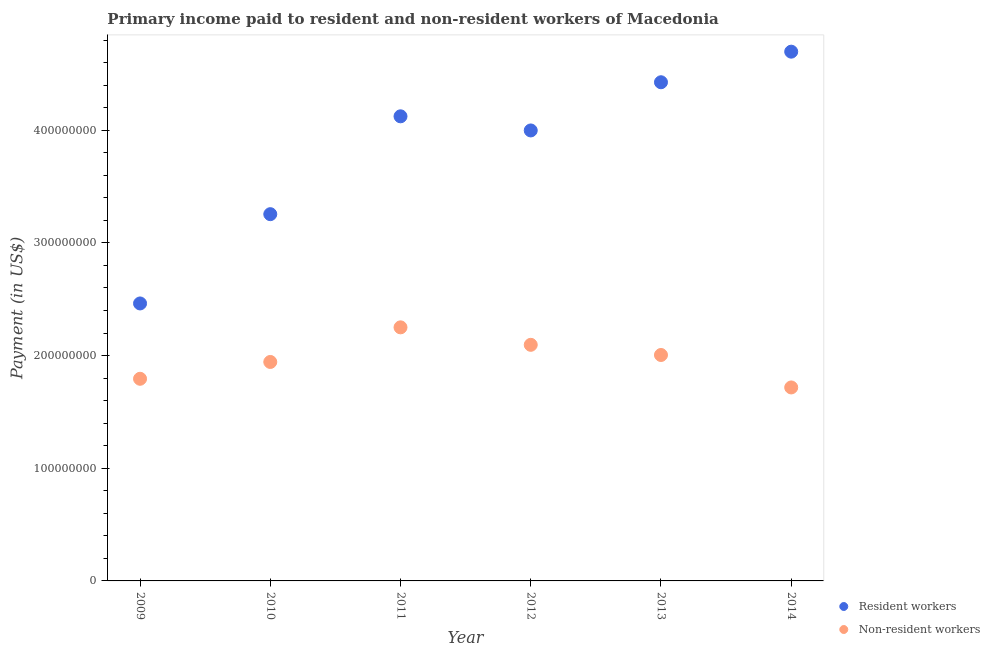Is the number of dotlines equal to the number of legend labels?
Ensure brevity in your answer.  Yes. What is the payment made to resident workers in 2013?
Make the answer very short. 4.43e+08. Across all years, what is the maximum payment made to non-resident workers?
Give a very brief answer. 2.25e+08. Across all years, what is the minimum payment made to non-resident workers?
Offer a very short reply. 1.72e+08. In which year was the payment made to resident workers maximum?
Your answer should be compact. 2014. In which year was the payment made to resident workers minimum?
Make the answer very short. 2009. What is the total payment made to resident workers in the graph?
Your answer should be very brief. 2.30e+09. What is the difference between the payment made to non-resident workers in 2009 and that in 2011?
Provide a succinct answer. -4.56e+07. What is the difference between the payment made to resident workers in 2014 and the payment made to non-resident workers in 2012?
Offer a terse response. 2.60e+08. What is the average payment made to resident workers per year?
Offer a very short reply. 3.83e+08. In the year 2011, what is the difference between the payment made to non-resident workers and payment made to resident workers?
Offer a very short reply. -1.87e+08. What is the ratio of the payment made to non-resident workers in 2010 to that in 2012?
Provide a succinct answer. 0.93. Is the payment made to non-resident workers in 2013 less than that in 2014?
Ensure brevity in your answer.  No. Is the difference between the payment made to resident workers in 2010 and 2014 greater than the difference between the payment made to non-resident workers in 2010 and 2014?
Your response must be concise. No. What is the difference between the highest and the second highest payment made to resident workers?
Make the answer very short. 2.71e+07. What is the difference between the highest and the lowest payment made to non-resident workers?
Give a very brief answer. 5.33e+07. Does the payment made to resident workers monotonically increase over the years?
Your answer should be compact. No. Is the payment made to resident workers strictly greater than the payment made to non-resident workers over the years?
Provide a succinct answer. Yes. Are the values on the major ticks of Y-axis written in scientific E-notation?
Ensure brevity in your answer.  No. Does the graph contain any zero values?
Provide a succinct answer. No. Does the graph contain grids?
Provide a succinct answer. No. How many legend labels are there?
Your answer should be very brief. 2. What is the title of the graph?
Give a very brief answer. Primary income paid to resident and non-resident workers of Macedonia. Does "Young" appear as one of the legend labels in the graph?
Your answer should be compact. No. What is the label or title of the Y-axis?
Keep it short and to the point. Payment (in US$). What is the Payment (in US$) in Resident workers in 2009?
Keep it short and to the point. 2.46e+08. What is the Payment (in US$) in Non-resident workers in 2009?
Your answer should be very brief. 1.79e+08. What is the Payment (in US$) of Resident workers in 2010?
Your answer should be very brief. 3.25e+08. What is the Payment (in US$) in Non-resident workers in 2010?
Your response must be concise. 1.94e+08. What is the Payment (in US$) of Resident workers in 2011?
Ensure brevity in your answer.  4.12e+08. What is the Payment (in US$) in Non-resident workers in 2011?
Make the answer very short. 2.25e+08. What is the Payment (in US$) of Resident workers in 2012?
Your answer should be compact. 4.00e+08. What is the Payment (in US$) in Non-resident workers in 2012?
Your answer should be compact. 2.10e+08. What is the Payment (in US$) in Resident workers in 2013?
Offer a terse response. 4.43e+08. What is the Payment (in US$) of Non-resident workers in 2013?
Provide a short and direct response. 2.01e+08. What is the Payment (in US$) of Resident workers in 2014?
Provide a succinct answer. 4.70e+08. What is the Payment (in US$) of Non-resident workers in 2014?
Your answer should be very brief. 1.72e+08. Across all years, what is the maximum Payment (in US$) of Resident workers?
Make the answer very short. 4.70e+08. Across all years, what is the maximum Payment (in US$) of Non-resident workers?
Ensure brevity in your answer.  2.25e+08. Across all years, what is the minimum Payment (in US$) of Resident workers?
Your answer should be very brief. 2.46e+08. Across all years, what is the minimum Payment (in US$) in Non-resident workers?
Offer a very short reply. 1.72e+08. What is the total Payment (in US$) of Resident workers in the graph?
Keep it short and to the point. 2.30e+09. What is the total Payment (in US$) in Non-resident workers in the graph?
Make the answer very short. 1.18e+09. What is the difference between the Payment (in US$) in Resident workers in 2009 and that in 2010?
Your answer should be compact. -7.92e+07. What is the difference between the Payment (in US$) in Non-resident workers in 2009 and that in 2010?
Give a very brief answer. -1.49e+07. What is the difference between the Payment (in US$) of Resident workers in 2009 and that in 2011?
Ensure brevity in your answer.  -1.66e+08. What is the difference between the Payment (in US$) of Non-resident workers in 2009 and that in 2011?
Offer a terse response. -4.56e+07. What is the difference between the Payment (in US$) in Resident workers in 2009 and that in 2012?
Offer a very short reply. -1.54e+08. What is the difference between the Payment (in US$) in Non-resident workers in 2009 and that in 2012?
Offer a terse response. -3.01e+07. What is the difference between the Payment (in US$) in Resident workers in 2009 and that in 2013?
Ensure brevity in your answer.  -1.96e+08. What is the difference between the Payment (in US$) of Non-resident workers in 2009 and that in 2013?
Provide a short and direct response. -2.11e+07. What is the difference between the Payment (in US$) in Resident workers in 2009 and that in 2014?
Keep it short and to the point. -2.23e+08. What is the difference between the Payment (in US$) of Non-resident workers in 2009 and that in 2014?
Ensure brevity in your answer.  7.68e+06. What is the difference between the Payment (in US$) of Resident workers in 2010 and that in 2011?
Ensure brevity in your answer.  -8.68e+07. What is the difference between the Payment (in US$) in Non-resident workers in 2010 and that in 2011?
Your response must be concise. -3.07e+07. What is the difference between the Payment (in US$) of Resident workers in 2010 and that in 2012?
Offer a very short reply. -7.43e+07. What is the difference between the Payment (in US$) in Non-resident workers in 2010 and that in 2012?
Your answer should be very brief. -1.52e+07. What is the difference between the Payment (in US$) of Resident workers in 2010 and that in 2013?
Your response must be concise. -1.17e+08. What is the difference between the Payment (in US$) of Non-resident workers in 2010 and that in 2013?
Provide a short and direct response. -6.19e+06. What is the difference between the Payment (in US$) in Resident workers in 2010 and that in 2014?
Your answer should be compact. -1.44e+08. What is the difference between the Payment (in US$) of Non-resident workers in 2010 and that in 2014?
Offer a terse response. 2.26e+07. What is the difference between the Payment (in US$) of Resident workers in 2011 and that in 2012?
Provide a succinct answer. 1.25e+07. What is the difference between the Payment (in US$) of Non-resident workers in 2011 and that in 2012?
Your answer should be very brief. 1.55e+07. What is the difference between the Payment (in US$) in Resident workers in 2011 and that in 2013?
Keep it short and to the point. -3.02e+07. What is the difference between the Payment (in US$) in Non-resident workers in 2011 and that in 2013?
Provide a short and direct response. 2.45e+07. What is the difference between the Payment (in US$) of Resident workers in 2011 and that in 2014?
Your answer should be compact. -5.74e+07. What is the difference between the Payment (in US$) of Non-resident workers in 2011 and that in 2014?
Offer a very short reply. 5.33e+07. What is the difference between the Payment (in US$) in Resident workers in 2012 and that in 2013?
Ensure brevity in your answer.  -4.28e+07. What is the difference between the Payment (in US$) in Non-resident workers in 2012 and that in 2013?
Keep it short and to the point. 9.02e+06. What is the difference between the Payment (in US$) of Resident workers in 2012 and that in 2014?
Offer a very short reply. -6.99e+07. What is the difference between the Payment (in US$) in Non-resident workers in 2012 and that in 2014?
Your response must be concise. 3.78e+07. What is the difference between the Payment (in US$) in Resident workers in 2013 and that in 2014?
Ensure brevity in your answer.  -2.71e+07. What is the difference between the Payment (in US$) of Non-resident workers in 2013 and that in 2014?
Provide a succinct answer. 2.88e+07. What is the difference between the Payment (in US$) of Resident workers in 2009 and the Payment (in US$) of Non-resident workers in 2010?
Offer a terse response. 5.19e+07. What is the difference between the Payment (in US$) of Resident workers in 2009 and the Payment (in US$) of Non-resident workers in 2011?
Your response must be concise. 2.12e+07. What is the difference between the Payment (in US$) of Resident workers in 2009 and the Payment (in US$) of Non-resident workers in 2012?
Your response must be concise. 3.67e+07. What is the difference between the Payment (in US$) of Resident workers in 2009 and the Payment (in US$) of Non-resident workers in 2013?
Offer a terse response. 4.57e+07. What is the difference between the Payment (in US$) in Resident workers in 2009 and the Payment (in US$) in Non-resident workers in 2014?
Provide a succinct answer. 7.45e+07. What is the difference between the Payment (in US$) in Resident workers in 2010 and the Payment (in US$) in Non-resident workers in 2011?
Ensure brevity in your answer.  1.00e+08. What is the difference between the Payment (in US$) in Resident workers in 2010 and the Payment (in US$) in Non-resident workers in 2012?
Your answer should be compact. 1.16e+08. What is the difference between the Payment (in US$) of Resident workers in 2010 and the Payment (in US$) of Non-resident workers in 2013?
Your answer should be very brief. 1.25e+08. What is the difference between the Payment (in US$) in Resident workers in 2010 and the Payment (in US$) in Non-resident workers in 2014?
Give a very brief answer. 1.54e+08. What is the difference between the Payment (in US$) in Resident workers in 2011 and the Payment (in US$) in Non-resident workers in 2012?
Your answer should be compact. 2.03e+08. What is the difference between the Payment (in US$) in Resident workers in 2011 and the Payment (in US$) in Non-resident workers in 2013?
Ensure brevity in your answer.  2.12e+08. What is the difference between the Payment (in US$) of Resident workers in 2011 and the Payment (in US$) of Non-resident workers in 2014?
Your answer should be very brief. 2.41e+08. What is the difference between the Payment (in US$) of Resident workers in 2012 and the Payment (in US$) of Non-resident workers in 2013?
Your answer should be very brief. 1.99e+08. What is the difference between the Payment (in US$) of Resident workers in 2012 and the Payment (in US$) of Non-resident workers in 2014?
Provide a short and direct response. 2.28e+08. What is the difference between the Payment (in US$) in Resident workers in 2013 and the Payment (in US$) in Non-resident workers in 2014?
Provide a succinct answer. 2.71e+08. What is the average Payment (in US$) of Resident workers per year?
Offer a terse response. 3.83e+08. What is the average Payment (in US$) in Non-resident workers per year?
Offer a very short reply. 1.97e+08. In the year 2009, what is the difference between the Payment (in US$) in Resident workers and Payment (in US$) in Non-resident workers?
Your answer should be compact. 6.69e+07. In the year 2010, what is the difference between the Payment (in US$) of Resident workers and Payment (in US$) of Non-resident workers?
Give a very brief answer. 1.31e+08. In the year 2011, what is the difference between the Payment (in US$) of Resident workers and Payment (in US$) of Non-resident workers?
Give a very brief answer. 1.87e+08. In the year 2012, what is the difference between the Payment (in US$) in Resident workers and Payment (in US$) in Non-resident workers?
Provide a short and direct response. 1.90e+08. In the year 2013, what is the difference between the Payment (in US$) of Resident workers and Payment (in US$) of Non-resident workers?
Keep it short and to the point. 2.42e+08. In the year 2014, what is the difference between the Payment (in US$) in Resident workers and Payment (in US$) in Non-resident workers?
Provide a short and direct response. 2.98e+08. What is the ratio of the Payment (in US$) of Resident workers in 2009 to that in 2010?
Make the answer very short. 0.76. What is the ratio of the Payment (in US$) of Non-resident workers in 2009 to that in 2010?
Keep it short and to the point. 0.92. What is the ratio of the Payment (in US$) of Resident workers in 2009 to that in 2011?
Provide a succinct answer. 0.6. What is the ratio of the Payment (in US$) of Non-resident workers in 2009 to that in 2011?
Provide a succinct answer. 0.8. What is the ratio of the Payment (in US$) in Resident workers in 2009 to that in 2012?
Your response must be concise. 0.62. What is the ratio of the Payment (in US$) in Non-resident workers in 2009 to that in 2012?
Offer a very short reply. 0.86. What is the ratio of the Payment (in US$) in Resident workers in 2009 to that in 2013?
Make the answer very short. 0.56. What is the ratio of the Payment (in US$) in Non-resident workers in 2009 to that in 2013?
Make the answer very short. 0.89. What is the ratio of the Payment (in US$) of Resident workers in 2009 to that in 2014?
Your answer should be very brief. 0.52. What is the ratio of the Payment (in US$) in Non-resident workers in 2009 to that in 2014?
Provide a short and direct response. 1.04. What is the ratio of the Payment (in US$) in Resident workers in 2010 to that in 2011?
Offer a very short reply. 0.79. What is the ratio of the Payment (in US$) of Non-resident workers in 2010 to that in 2011?
Keep it short and to the point. 0.86. What is the ratio of the Payment (in US$) in Resident workers in 2010 to that in 2012?
Your response must be concise. 0.81. What is the ratio of the Payment (in US$) in Non-resident workers in 2010 to that in 2012?
Offer a very short reply. 0.93. What is the ratio of the Payment (in US$) in Resident workers in 2010 to that in 2013?
Make the answer very short. 0.74. What is the ratio of the Payment (in US$) in Non-resident workers in 2010 to that in 2013?
Your answer should be very brief. 0.97. What is the ratio of the Payment (in US$) in Resident workers in 2010 to that in 2014?
Provide a short and direct response. 0.69. What is the ratio of the Payment (in US$) of Non-resident workers in 2010 to that in 2014?
Offer a very short reply. 1.13. What is the ratio of the Payment (in US$) of Resident workers in 2011 to that in 2012?
Your response must be concise. 1.03. What is the ratio of the Payment (in US$) of Non-resident workers in 2011 to that in 2012?
Provide a succinct answer. 1.07. What is the ratio of the Payment (in US$) of Resident workers in 2011 to that in 2013?
Offer a terse response. 0.93. What is the ratio of the Payment (in US$) in Non-resident workers in 2011 to that in 2013?
Give a very brief answer. 1.12. What is the ratio of the Payment (in US$) in Resident workers in 2011 to that in 2014?
Offer a very short reply. 0.88. What is the ratio of the Payment (in US$) in Non-resident workers in 2011 to that in 2014?
Make the answer very short. 1.31. What is the ratio of the Payment (in US$) of Resident workers in 2012 to that in 2013?
Provide a short and direct response. 0.9. What is the ratio of the Payment (in US$) in Non-resident workers in 2012 to that in 2013?
Your answer should be compact. 1.04. What is the ratio of the Payment (in US$) of Resident workers in 2012 to that in 2014?
Keep it short and to the point. 0.85. What is the ratio of the Payment (in US$) in Non-resident workers in 2012 to that in 2014?
Make the answer very short. 1.22. What is the ratio of the Payment (in US$) in Resident workers in 2013 to that in 2014?
Your answer should be very brief. 0.94. What is the ratio of the Payment (in US$) in Non-resident workers in 2013 to that in 2014?
Ensure brevity in your answer.  1.17. What is the difference between the highest and the second highest Payment (in US$) of Resident workers?
Provide a succinct answer. 2.71e+07. What is the difference between the highest and the second highest Payment (in US$) of Non-resident workers?
Make the answer very short. 1.55e+07. What is the difference between the highest and the lowest Payment (in US$) in Resident workers?
Keep it short and to the point. 2.23e+08. What is the difference between the highest and the lowest Payment (in US$) in Non-resident workers?
Make the answer very short. 5.33e+07. 